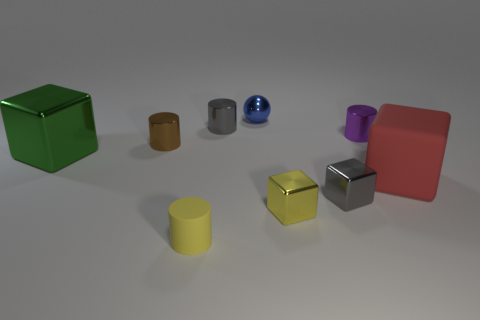Subtract all small gray cubes. How many cubes are left? 3 Subtract all red blocks. How many blocks are left? 3 Add 1 small gray metal cubes. How many objects exist? 10 Subtract 2 cylinders. How many cylinders are left? 2 Subtract all cylinders. How many objects are left? 5 Subtract 0 blue blocks. How many objects are left? 9 Subtract all green cylinders. Subtract all green balls. How many cylinders are left? 4 Subtract all brown objects. Subtract all yellow cylinders. How many objects are left? 7 Add 7 tiny blocks. How many tiny blocks are left? 9 Add 7 big brown shiny things. How many big brown shiny things exist? 7 